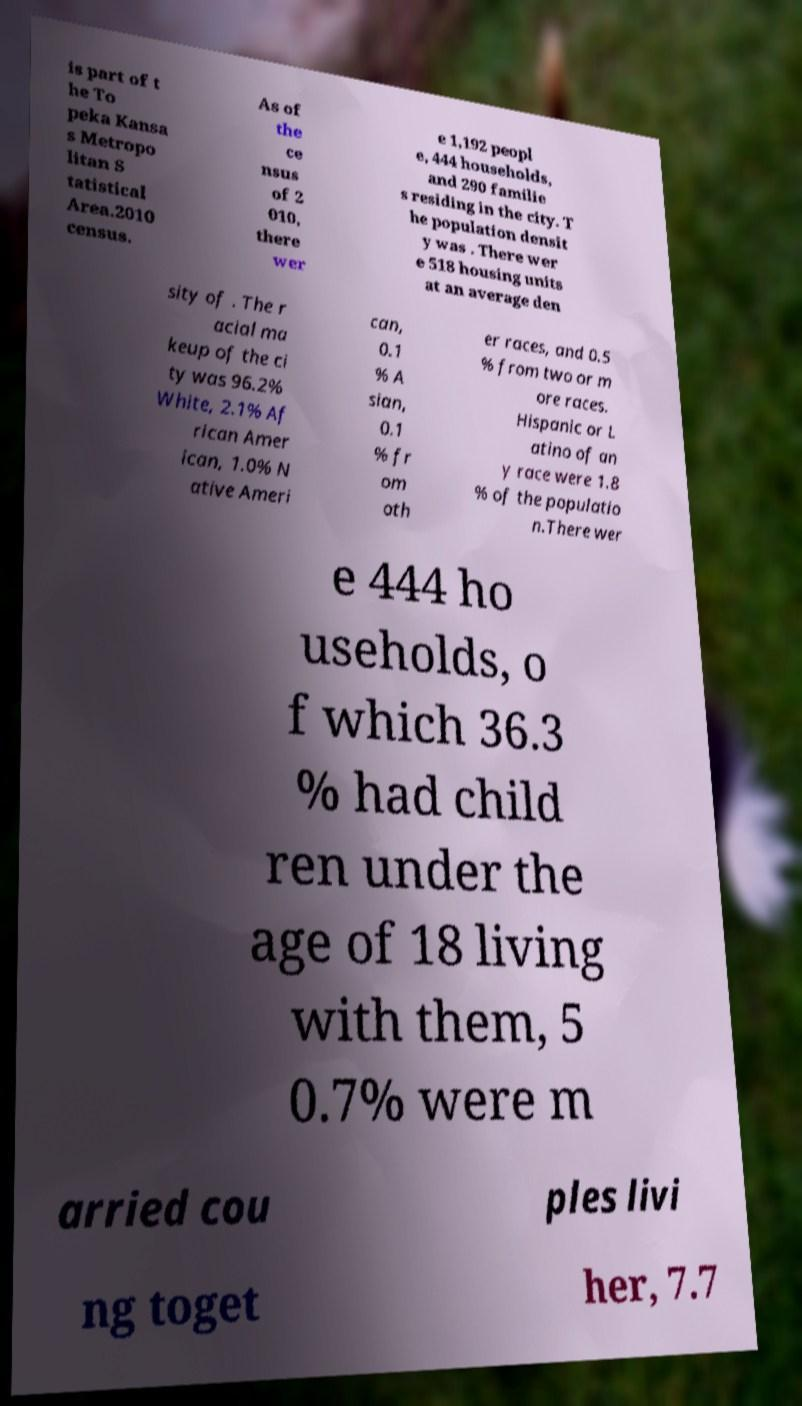There's text embedded in this image that I need extracted. Can you transcribe it verbatim? is part of t he To peka Kansa s Metropo litan S tatistical Area.2010 census. As of the ce nsus of 2 010, there wer e 1,192 peopl e, 444 households, and 290 familie s residing in the city. T he population densit y was . There wer e 518 housing units at an average den sity of . The r acial ma keup of the ci ty was 96.2% White, 2.1% Af rican Amer ican, 1.0% N ative Ameri can, 0.1 % A sian, 0.1 % fr om oth er races, and 0.5 % from two or m ore races. Hispanic or L atino of an y race were 1.8 % of the populatio n.There wer e 444 ho useholds, o f which 36.3 % had child ren under the age of 18 living with them, 5 0.7% were m arried cou ples livi ng toget her, 7.7 